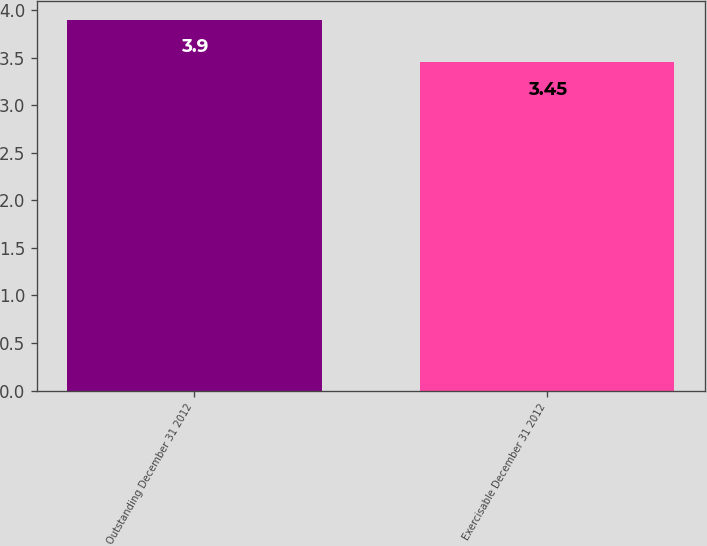<chart> <loc_0><loc_0><loc_500><loc_500><bar_chart><fcel>Outstanding December 31 2012<fcel>Exercisable December 31 2012<nl><fcel>3.9<fcel>3.45<nl></chart> 